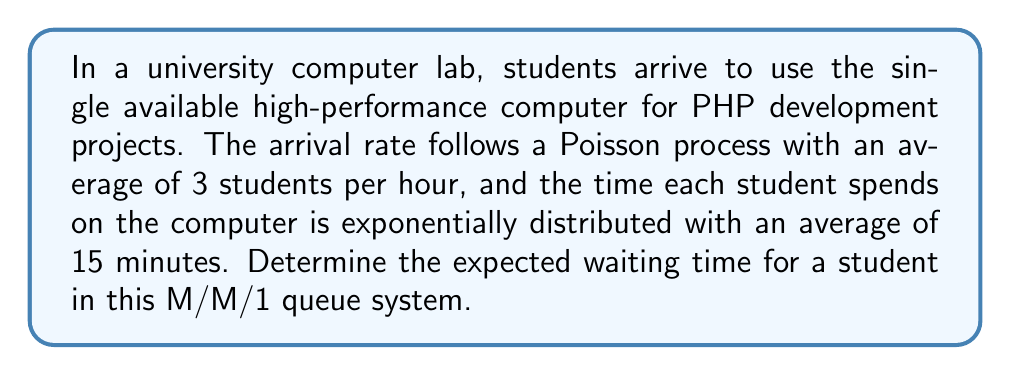Solve this math problem. To solve this problem, we'll use the formula for the expected waiting time in an M/M/1 queue system and follow these steps:

1. Identify the arrival rate (λ) and service rate (μ):
   λ = 3 students/hour
   μ = 4 students/hour (since 1 hour / 0.25 hours = 4)

2. Calculate the utilization factor (ρ):
   $$\rho = \frac{\lambda}{\mu} = \frac{3}{4} = 0.75$$

3. Use the formula for expected waiting time in an M/M/1 queue:
   $$W_q = \frac{\rho}{\mu - \lambda} = \frac{\rho}{\mu(1 - \rho)}$$

4. Substitute the values:
   $$W_q = \frac{0.75}{4(1 - 0.75)} = \frac{0.75}{4 * 0.25} = \frac{0.75}{1} = 0.75$$

5. Convert the result to minutes:
   0.75 hours * 60 minutes/hour = 45 minutes

Therefore, the expected waiting time for a student in this M/M/1 queue system is 45 minutes.
Answer: 45 minutes 